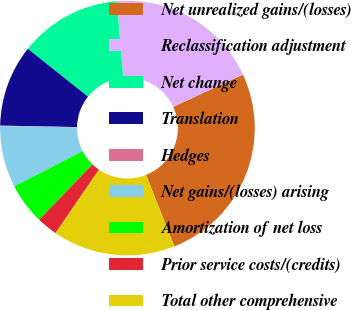<chart> <loc_0><loc_0><loc_500><loc_500><pie_chart><fcel>Net unrealized gains/(losses)<fcel>Reclassification adjustment<fcel>Net change<fcel>Translation<fcel>Hedges<fcel>Net gains/(losses) arising<fcel>Amortization of net loss<fcel>Prior service costs/(credits)<fcel>Total other comprehensive<nl><fcel>25.89%<fcel>19.42%<fcel>12.98%<fcel>10.39%<fcel>0.06%<fcel>7.81%<fcel>5.23%<fcel>2.65%<fcel>15.56%<nl></chart> 